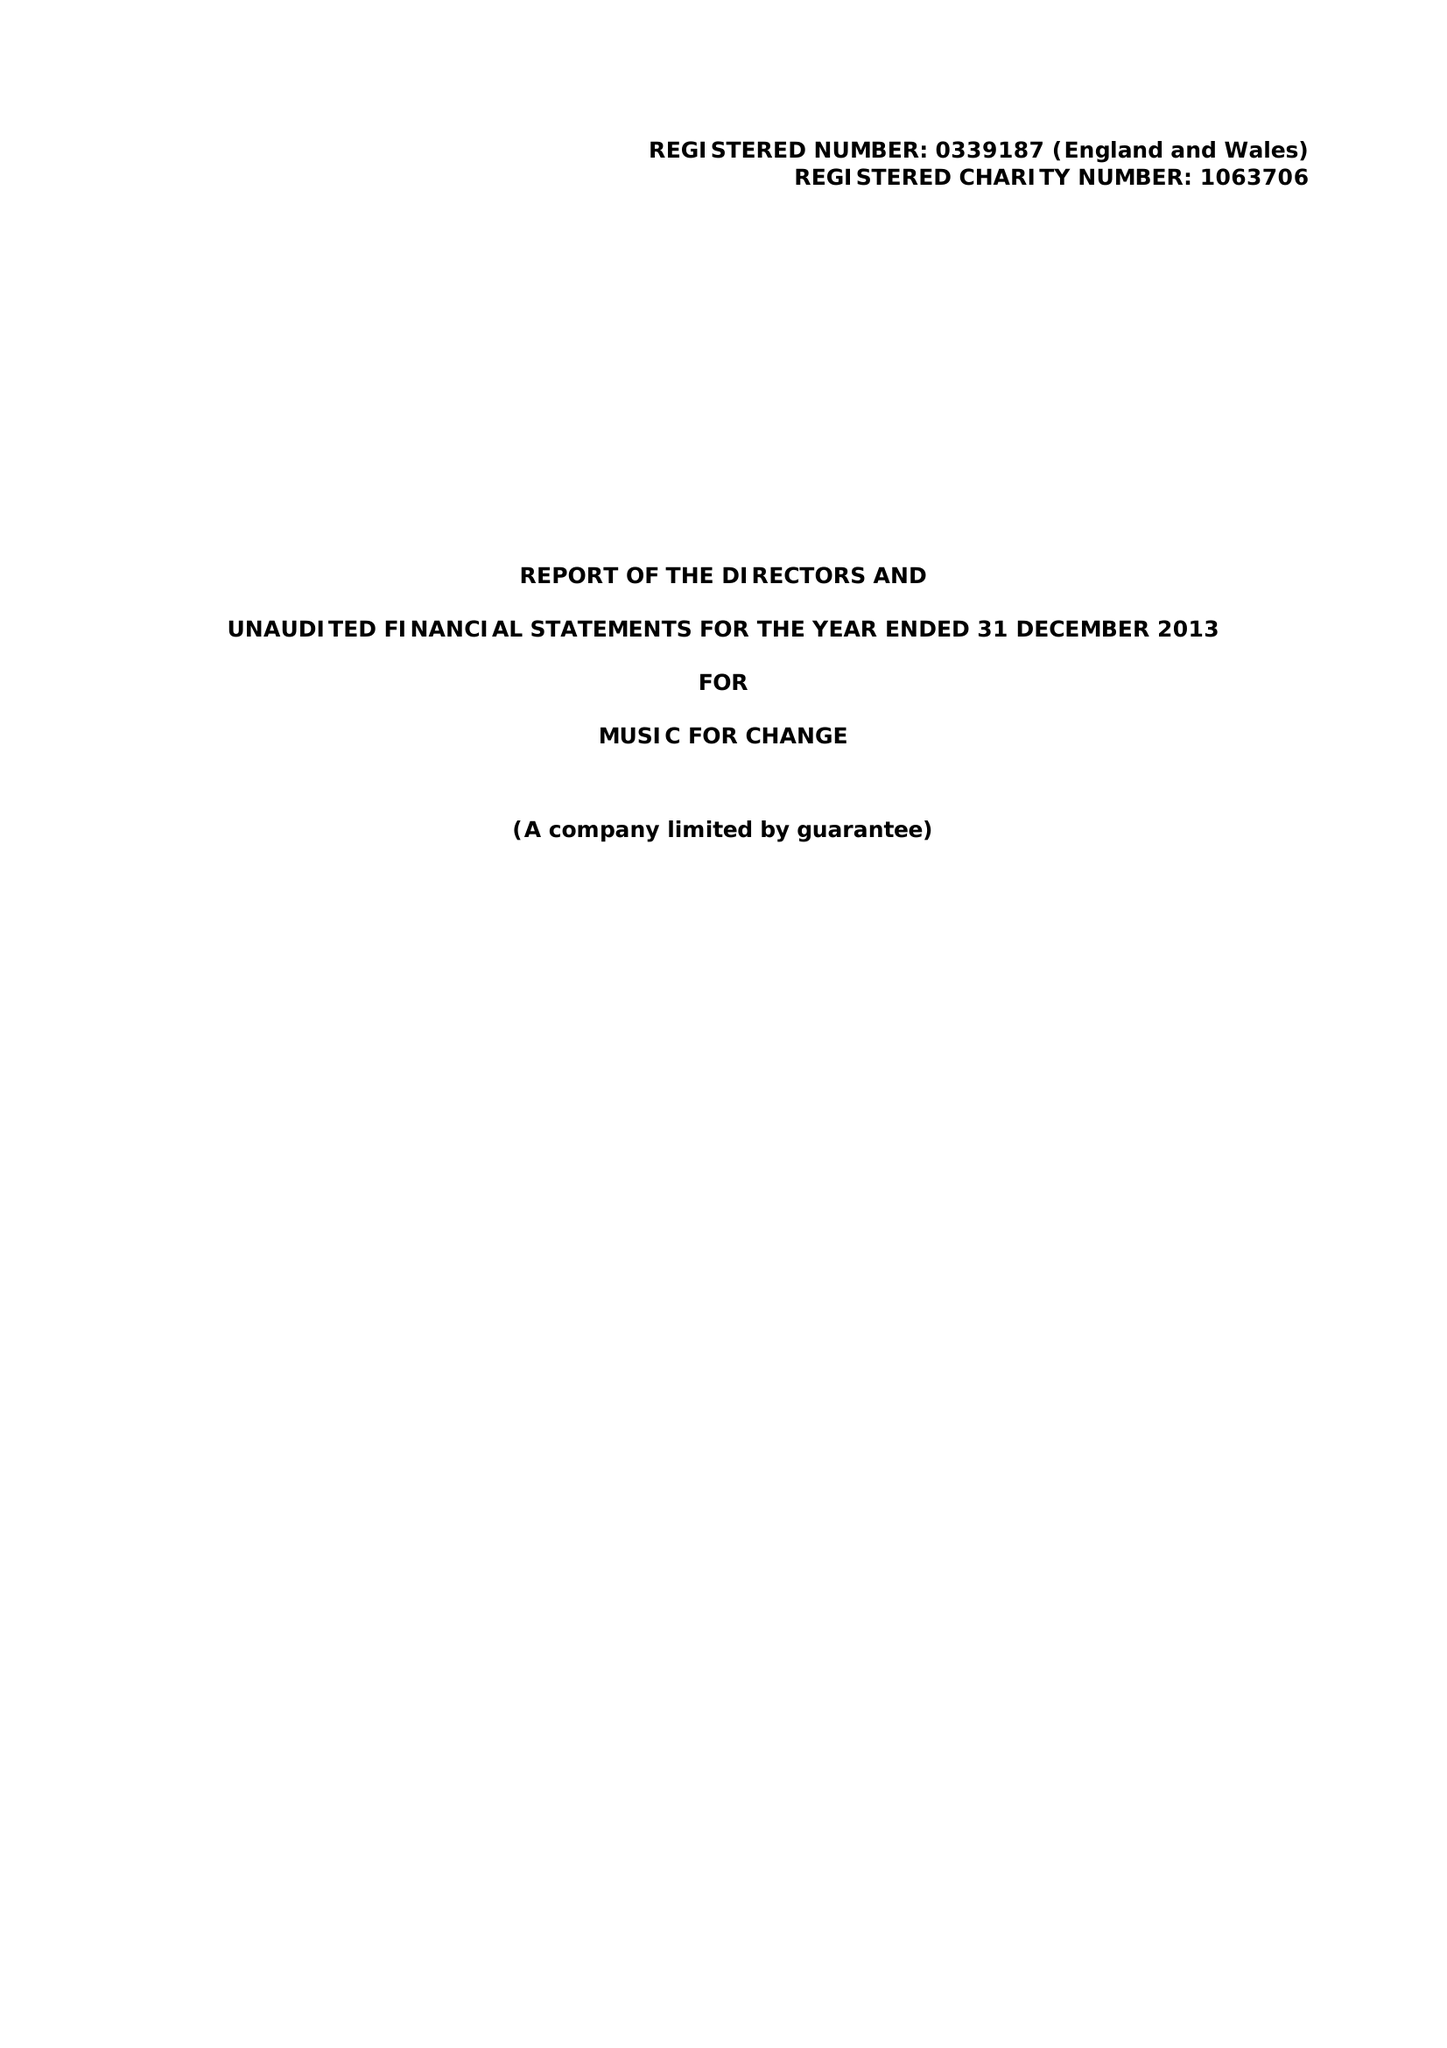What is the value for the address__postcode?
Answer the question using a single word or phrase. CT1 2NR 